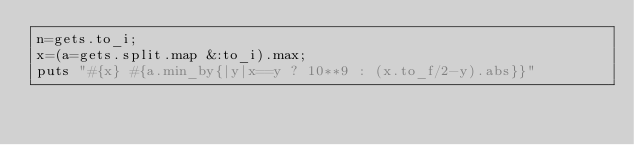<code> <loc_0><loc_0><loc_500><loc_500><_Ruby_>n=gets.to_i;
x=(a=gets.split.map &:to_i).max;
puts "#{x} #{a.min_by{|y|x==y ? 10**9 : (x.to_f/2-y).abs}}"</code> 